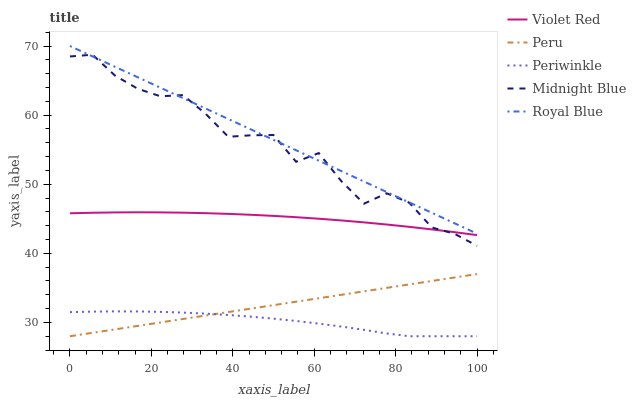Does Violet Red have the minimum area under the curve?
Answer yes or no. No. Does Violet Red have the maximum area under the curve?
Answer yes or no. No. Is Violet Red the smoothest?
Answer yes or no. No. Is Violet Red the roughest?
Answer yes or no. No. Does Violet Red have the lowest value?
Answer yes or no. No. Does Violet Red have the highest value?
Answer yes or no. No. Is Periwinkle less than Midnight Blue?
Answer yes or no. Yes. Is Midnight Blue greater than Peru?
Answer yes or no. Yes. Does Periwinkle intersect Midnight Blue?
Answer yes or no. No. 